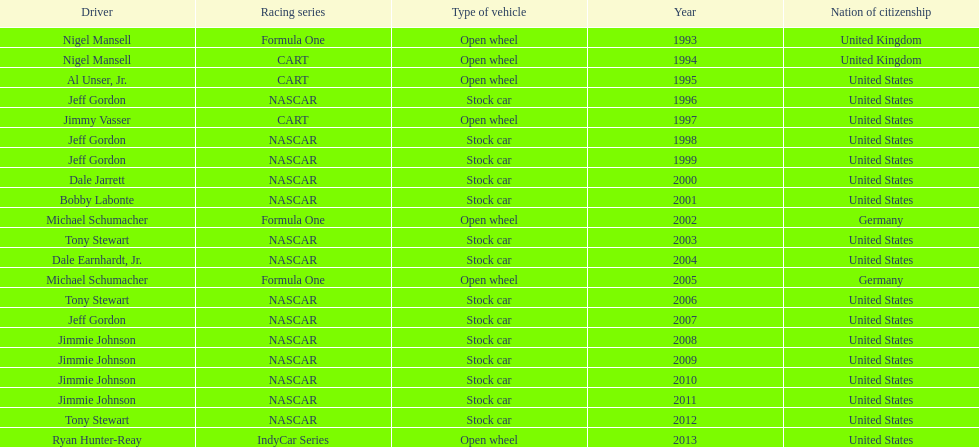Which racing series has the highest total of winners? NASCAR. 